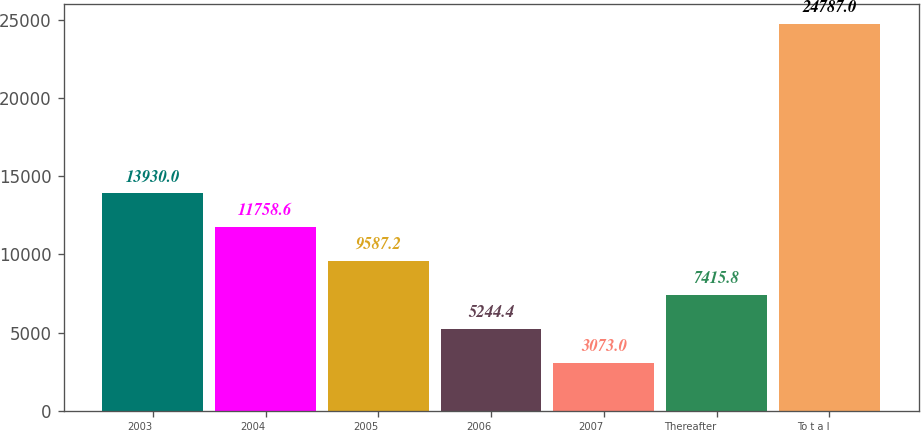Convert chart. <chart><loc_0><loc_0><loc_500><loc_500><bar_chart><fcel>2003<fcel>2004<fcel>2005<fcel>2006<fcel>2007<fcel>Thereafter<fcel>To t a l<nl><fcel>13930<fcel>11758.6<fcel>9587.2<fcel>5244.4<fcel>3073<fcel>7415.8<fcel>24787<nl></chart> 